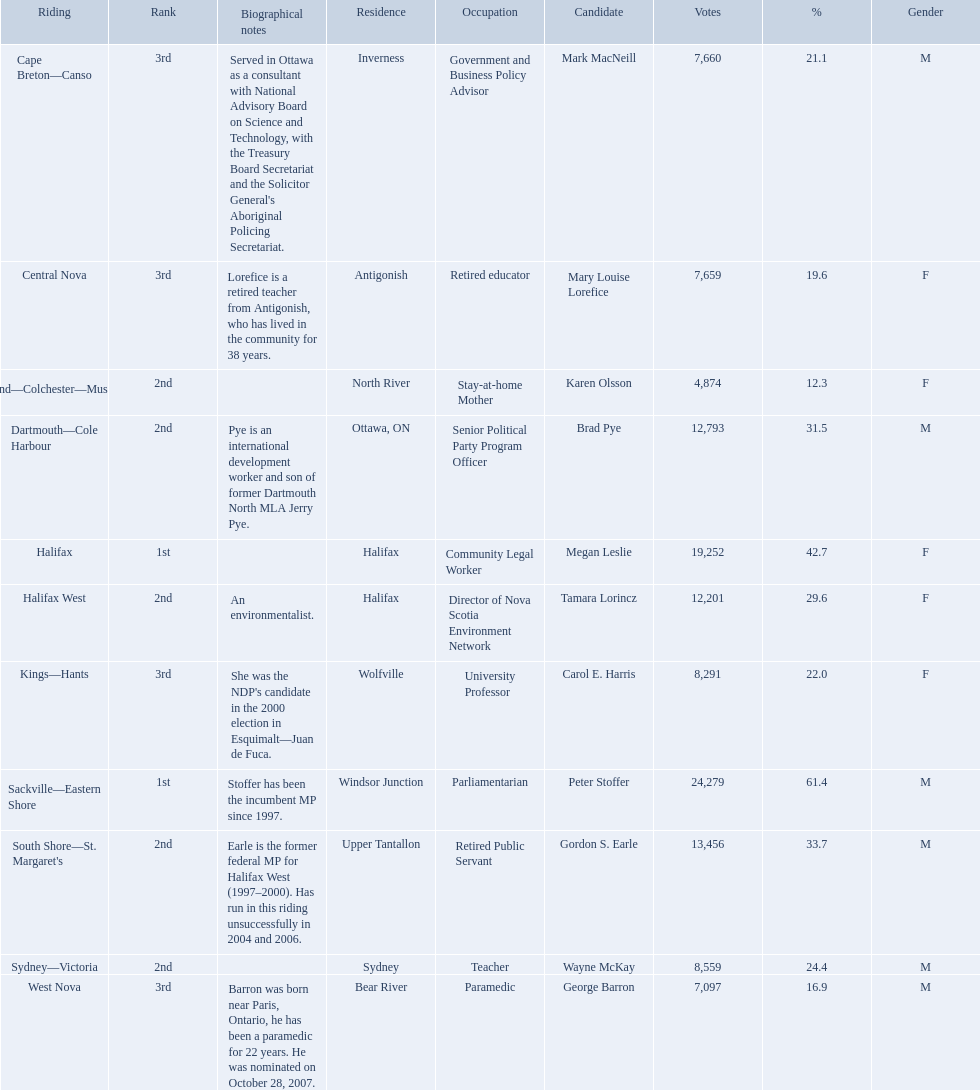Which candidates have the four lowest amount of votes Mark MacNeill, Mary Louise Lorefice, Karen Olsson, George Barron. Out of the following, who has the third most? Mark MacNeill. 